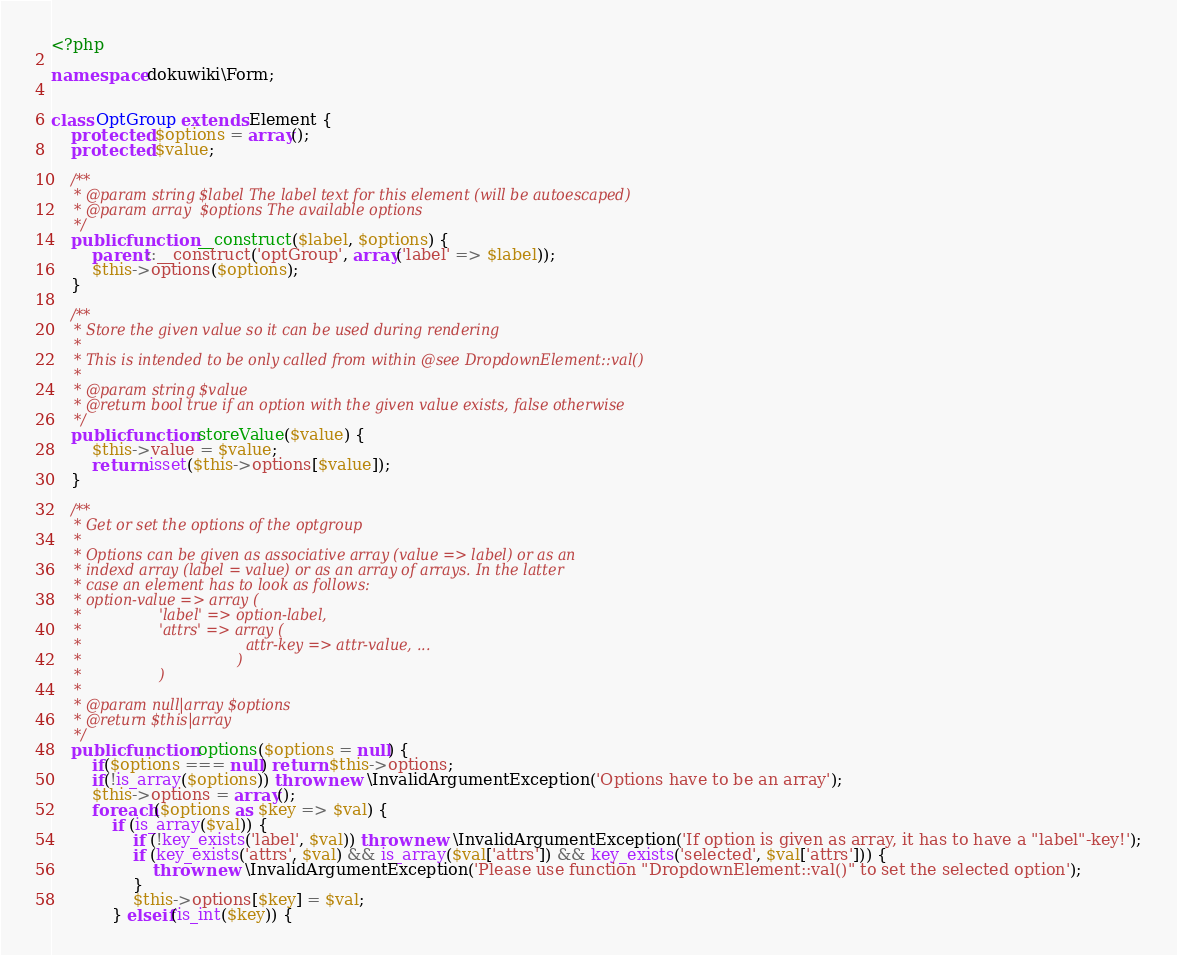Convert code to text. <code><loc_0><loc_0><loc_500><loc_500><_PHP_><?php

namespace dokuwiki\Form;


class OptGroup extends Element {
    protected $options = array();
    protected $value;

    /**
     * @param string $label The label text for this element (will be autoescaped)
     * @param array  $options The available options
     */
    public function __construct($label, $options) {
        parent::__construct('optGroup', array('label' => $label));
        $this->options($options);
    }

    /**
     * Store the given value so it can be used during rendering
     *
     * This is intended to be only called from within @see DropdownElement::val()
     *
     * @param string $value
     * @return bool true if an option with the given value exists, false otherwise
     */
    public function storeValue($value) {
        $this->value = $value;
        return isset($this->options[$value]);
    }

    /**
     * Get or set the options of the optgroup
     *
     * Options can be given as associative array (value => label) or as an
     * indexd array (label = value) or as an array of arrays. In the latter
     * case an element has to look as follows:
     * option-value => array (
     *                 'label' => option-label,
     *                 'attrs' => array (
     *                                    attr-key => attr-value, ...
     *                                  )
     *                 )
     *
     * @param null|array $options
     * @return $this|array
     */
    public function options($options = null) {
        if($options === null) return $this->options;
        if(!is_array($options)) throw new \InvalidArgumentException('Options have to be an array');
        $this->options = array();
        foreach($options as $key => $val) {
            if (is_array($val)) {
                if (!key_exists('label', $val)) throw new \InvalidArgumentException('If option is given as array, it has to have a "label"-key!');
                if (key_exists('attrs', $val) && is_array($val['attrs']) && key_exists('selected', $val['attrs'])) {
                    throw new \InvalidArgumentException('Please use function "DropdownElement::val()" to set the selected option');
                }
                $this->options[$key] = $val;
            } elseif(is_int($key)) {</code> 